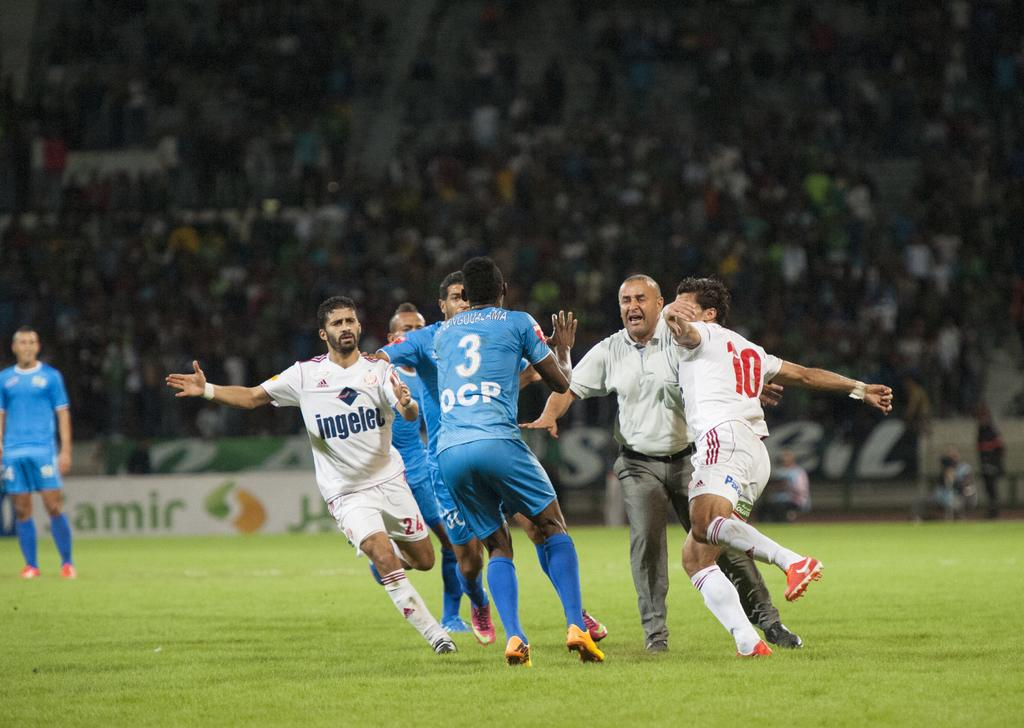<image>
Present a compact description of the photo's key features. Soccer players with the number 3 and number 10 seem to be about to collide. 